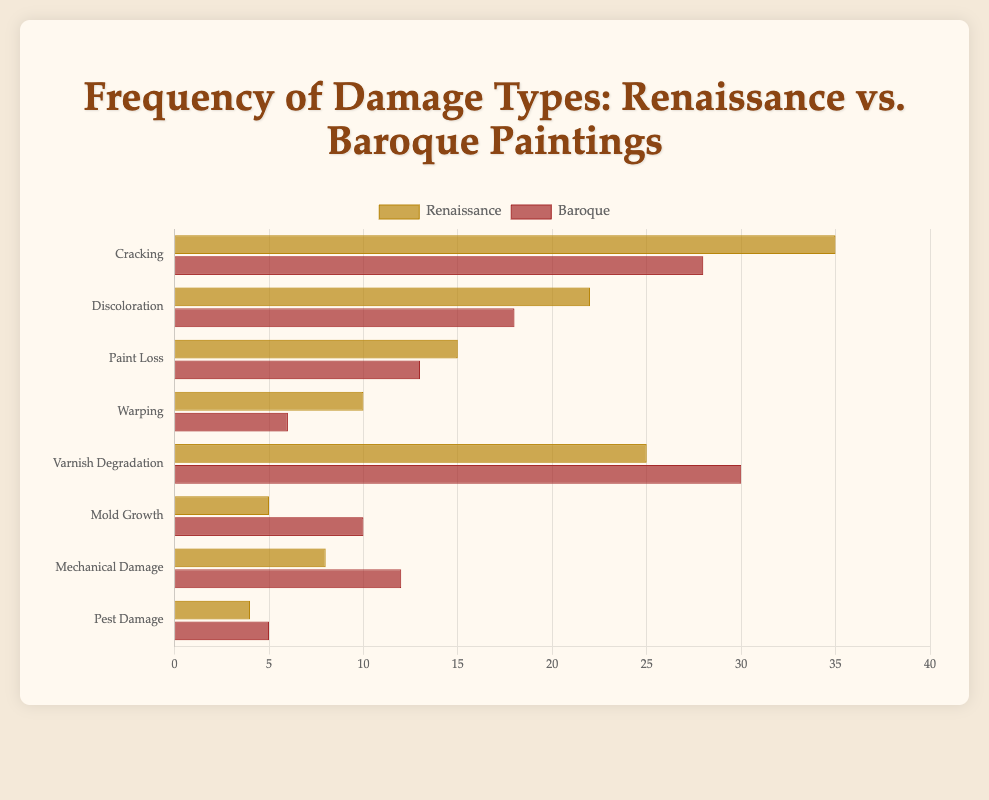Which damage type has the highest frequency in Renaissance paintings? Looking at the bar chart for Renaissance paintings, the "Cracking" bar is the longest, indicating it has the highest frequency at 35.
Answer: Cracking Which damage type shows a higher frequency in Baroque paintings compared to Renaissance paintings? By visually comparing the lengths of the corresponding bars, "Varnish Degradation" (30 vs. 25), "Mold Growth" (10 vs. 5), "Mechanical Damage" (12 vs. 8), and "Pest Damage" (5 vs. 4) are higher in Baroque paintings.
Answer: Varnish Degradation, Mold Growth, Mechanical Damage, Pest Damage Which period has a higher total number of instances of "Mechanical Damage" and "Pest Damage"? Summing the frequencies of "Mechanical Damage" (8) and "Pest Damage" (4) for Renaissance gives 8 + 4 = 12, and for Baroque (12) + (5) gives 12 + 5 = 17. Baroque has a higher total number.
Answer: Baroque How many more instances of "Warping" are observed in Renaissance paintings compared to Baroque paintings? Subtracting the number for Baroque paintings (6) from that of Renaissance paintings (10) gives 10 - 6 = 4 more instances.
Answer: 4 What is the sum of the frequencies for the damage types with the highest instances in both periods? The highest instances are "Cracking" (35) in Renaissance and "Varnish Degradation" (30) in Baroque. Summing these gives 35 + 30 = 65.
Answer: 65 Which type of damage shows nearly equal frequencies in both periods? By visually inspecting the chart, "Pest Damage" has nearly equal frequencies in Renaissance (4) and Baroque (5).
Answer: Pest Damage Compare the frequency of "Paint Loss" in Renaissance and Baroque paintings. Which period has fewer instances and by how many? Renaissance has 15 instances, and Baroque has 13. Baroque has fewer instances by 15 - 13 = 2.
Answer: Baroque, by 2 What is the average frequency of "Discoloration" and "Paint Loss" in Renaissance paintings? Adding frequencies of "Discoloration" (22) and "Paint Loss" (15) gives 22 + 15 = 37. Dividing by 2 gives 37 ÷ 2 = 18.5.
Answer: 18.5 How would you describe the visual contrast between the "Renaissance" and "Baroque" bars for "Mold Growth"? The "Mold Growth" bar for Baroque is twice as long as that for Renaissance, visually indicating a significantly higher frequency (10 vs. 5).
Answer: Baroque has a visually taller bar for Mold Growth 